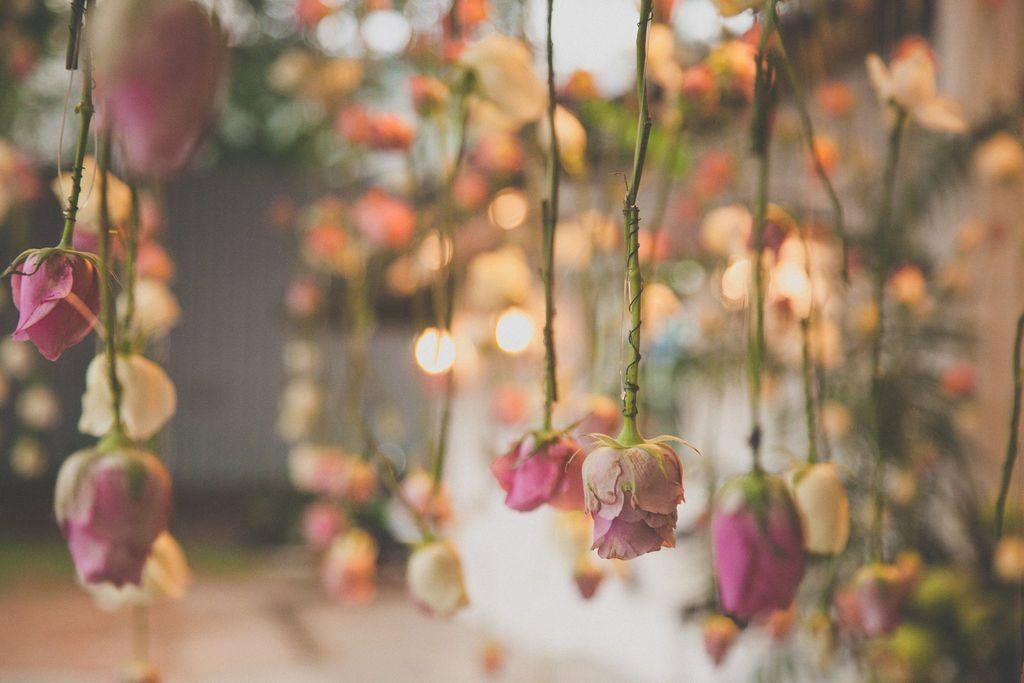What type of flowers are hanging in the image? Roses are hanging in the image. What else can be seen in the image besides the roses? There are lights in the image. Can you describe the background of the image? The background of the image is blurry. What type of summer clothing can be seen in the image? There is no mention of summer clothing in the image, as the facts provided do not include any information about clothing. 